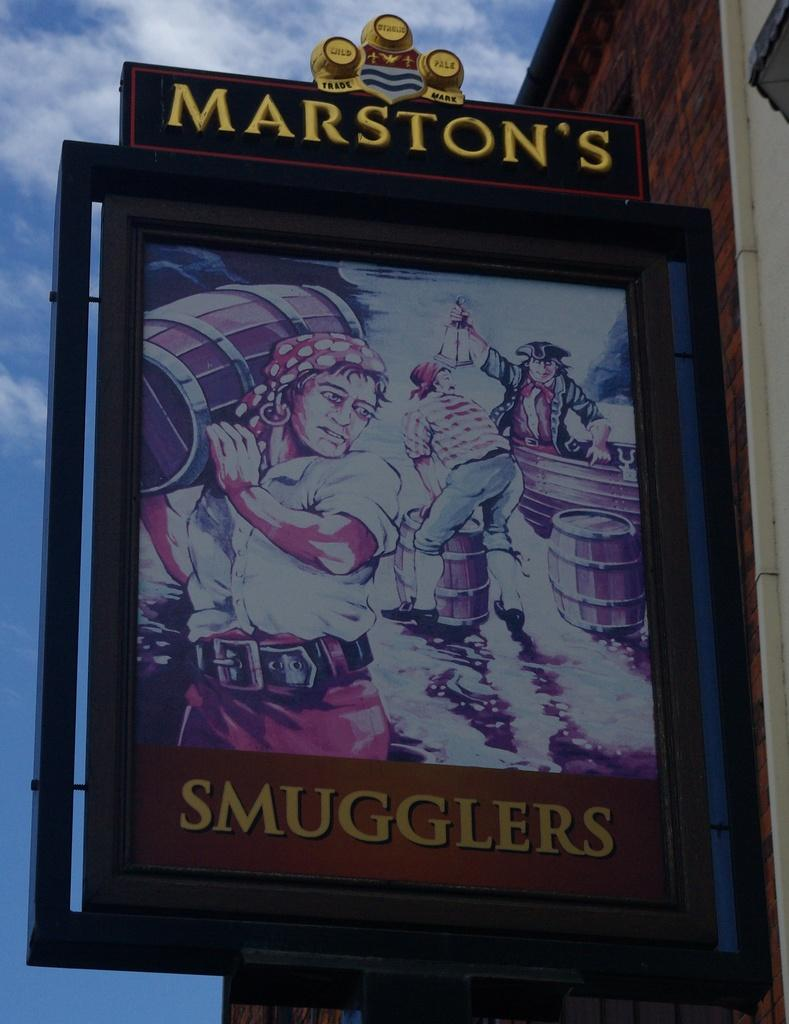<image>
Relay a brief, clear account of the picture shown. Marston's Smugglers is displayed on this old time pub advertisement. 